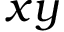<formula> <loc_0><loc_0><loc_500><loc_500>x y</formula> 